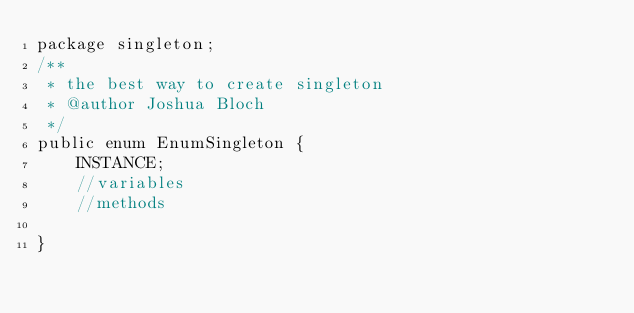Convert code to text. <code><loc_0><loc_0><loc_500><loc_500><_Java_>package singleton;
/**
 * the best way to create singleton
 * @author Joshua Bloch
 */
public enum EnumSingleton {
	INSTANCE;
	//variables
	//methods

}
</code> 